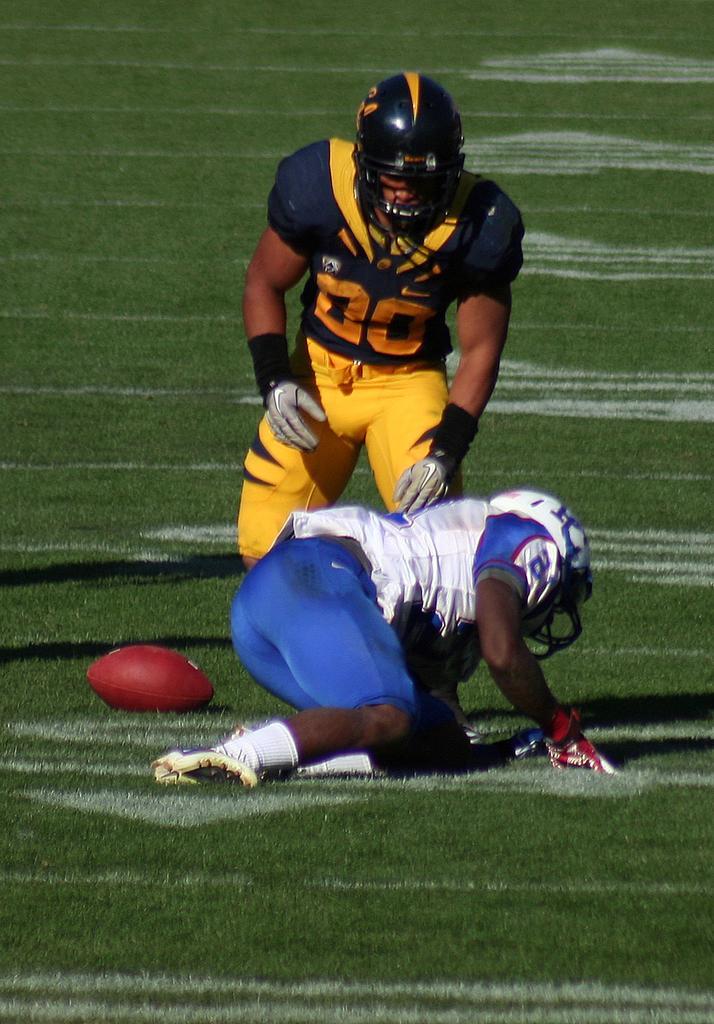Describe this image in one or two sentences. In the image there are two players, the first player is falling on the ground and the second player is standing and there is a ball beside the players on the ground. 